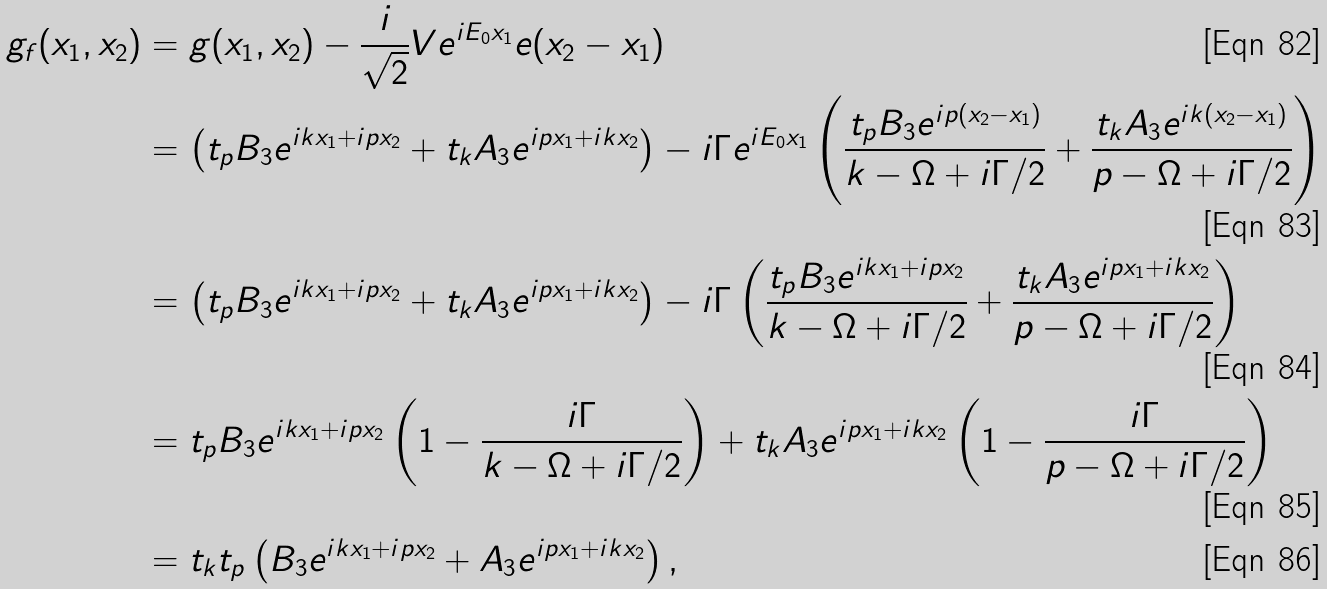Convert formula to latex. <formula><loc_0><loc_0><loc_500><loc_500>g _ { f } ( x _ { 1 } , x _ { 2 } ) & = g ( x _ { 1 } , x _ { 2 } ) - \frac { i } { \sqrt { 2 } } V e ^ { i E _ { 0 } x _ { 1 } } e ( x _ { 2 } - x _ { 1 } ) \\ & = \left ( t _ { p } B _ { 3 } e ^ { i k x _ { 1 } + i p x _ { 2 } } + t _ { k } A _ { 3 } e ^ { i p x _ { 1 } + i k x _ { 2 } } \right ) - i \Gamma e ^ { i E _ { 0 } x _ { 1 } } \left ( \frac { t _ { p } B _ { 3 } e ^ { i p ( x _ { 2 } - x _ { 1 } ) } } { k - \Omega + i \Gamma / 2 } + \frac { t _ { k } A _ { 3 } e ^ { i k ( x _ { 2 } - x _ { 1 } ) } } { p - \Omega + i \Gamma / 2 } \right ) \\ & = \left ( t _ { p } B _ { 3 } e ^ { i k x _ { 1 } + i p x _ { 2 } } + t _ { k } A _ { 3 } e ^ { i p x _ { 1 } + i k x _ { 2 } } \right ) - i \Gamma \left ( \frac { t _ { p } B _ { 3 } e ^ { i k x _ { 1 } + i p x _ { 2 } } } { k - \Omega + i \Gamma / 2 } + \frac { t _ { k } A _ { 3 } e ^ { i p x _ { 1 } + i k x _ { 2 } } } { p - \Omega + i \Gamma / 2 } \right ) \\ & = t _ { p } B _ { 3 } e ^ { i k x _ { 1 } + i p x _ { 2 } } \left ( 1 - \frac { i \Gamma } { k - \Omega + i \Gamma / 2 } \right ) + t _ { k } A _ { 3 } e ^ { i p x _ { 1 } + i k x _ { 2 } } \left ( 1 - \frac { i \Gamma } { p - \Omega + i \Gamma / 2 } \right ) \\ & = t _ { k } t _ { p } \left ( B _ { 3 } e ^ { i k x _ { 1 } + i p x _ { 2 } } + A _ { 3 } e ^ { i p x _ { 1 } + i k x _ { 2 } } \right ) ,</formula> 